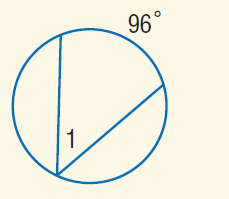Answer the mathemtical geometry problem and directly provide the correct option letter.
Question: Find m \angle 1.
Choices: A: \pi B: 48 C: 96 D: 360 B 